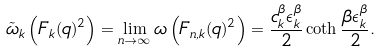<formula> <loc_0><loc_0><loc_500><loc_500>\tilde { \omega } _ { k } \left ( F _ { k } ( q ) ^ { 2 } \right ) = \lim _ { n \to \infty } \omega \left ( F _ { n , k } ( q ) ^ { 2 } \right ) = \frac { c ^ { \beta } _ { k } \epsilon ^ { \beta } _ { k } } { 2 } \coth \frac { \beta \epsilon ^ { \beta } _ { k } } { 2 } .</formula> 